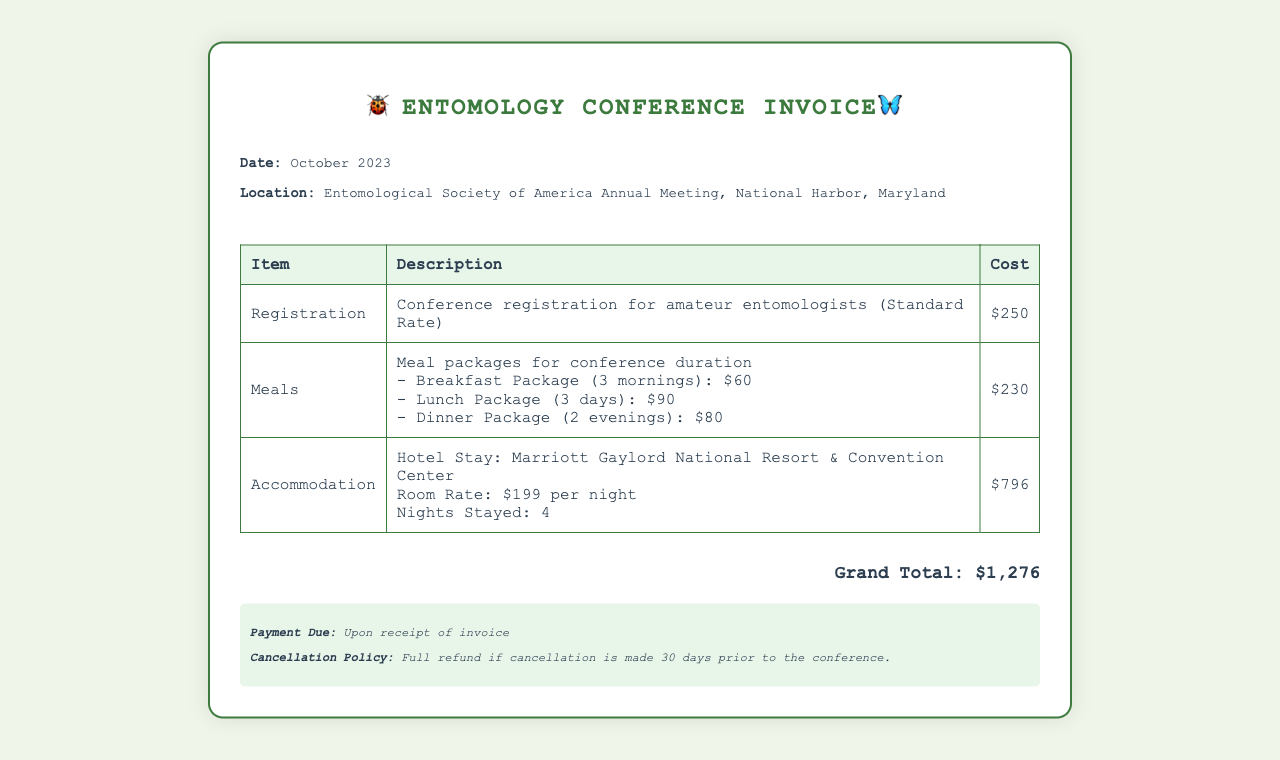What is the date of the conference? The date mentioned in the document is October 2023.
Answer: October 2023 What is the total cost for meals? The total cost for meals is specified in the document as $230.
Answer: $230 What is the room rate per night? The room rate for accommodations is stated as $199 per night in the document.
Answer: $199 How many nights was the accommodation booked for? The document states that the accommodation was booked for 4 nights.
Answer: 4 What is the grand total amount due? The grand total amount at the bottom of the document is specified as $1,276.
Answer: $1,276 What is the cancellation policy? The cancellation policy states a full refund if cancellation is made 30 days prior to the conference.
Answer: Full refund if cancellation is made 30 days prior to the conference What meals are included in the meal package? The meal package includes Breakfast, Lunch, and Dinner, as itemized in the meals section.
Answer: Breakfast, Lunch, Dinner What is the location of the conference? The location mentioned in the document is the Entomological Society of America Annual Meeting, National Harbor, Maryland.
Answer: National Harbor, Maryland 